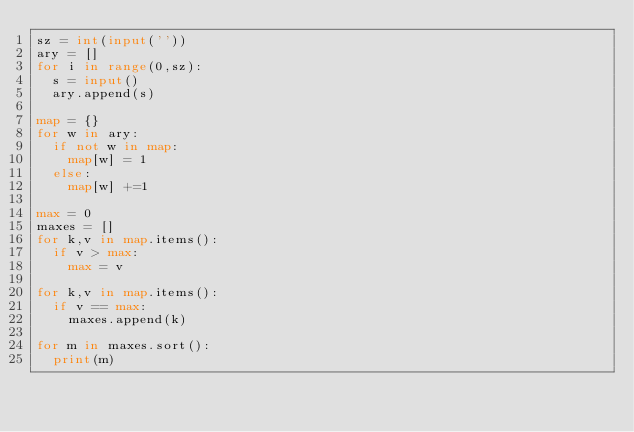Convert code to text. <code><loc_0><loc_0><loc_500><loc_500><_Python_>sz = int(input(''))
ary = []
for i in range(0,sz):
  s = input()
  ary.append(s)

map = {}
for w in ary:
  if not w in map:
    map[w] = 1
  else:
    map[w] +=1

max = 0
maxes = []
for k,v in map.items():
  if v > max:
    max = v

for k,v in map.items():
  if v == max:
    maxes.append(k)

for m in maxes.sort():
  print(m)</code> 